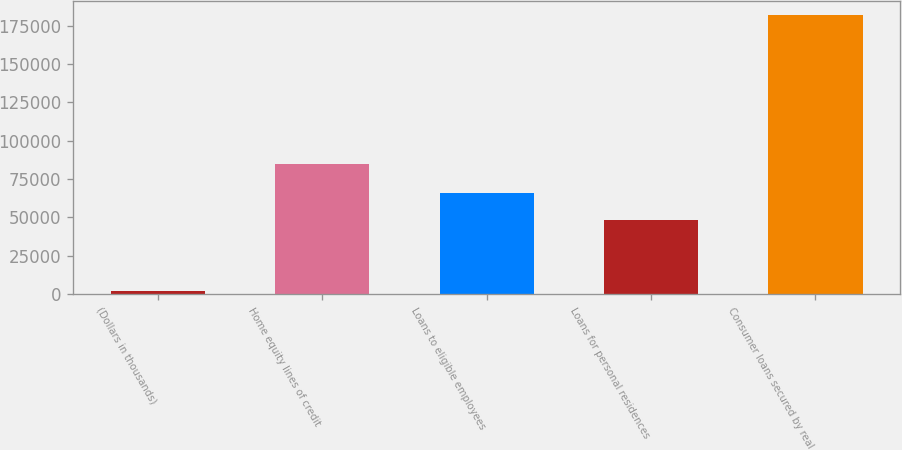Convert chart to OTSL. <chart><loc_0><loc_0><loc_500><loc_500><bar_chart><fcel>(Dollars in thousands)<fcel>Home equity lines of credit<fcel>Loans to eligible employees<fcel>Loans for personal residences<fcel>Consumer loans secured by real<nl><fcel>2007<fcel>84808<fcel>66050<fcel>48066<fcel>181847<nl></chart> 